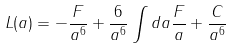<formula> <loc_0><loc_0><loc_500><loc_500>L ( a ) = - \frac { F } { a ^ { 6 } } + \frac { 6 } { a ^ { 6 } } \int d a \frac { F } { a } + \frac { C } { a ^ { 6 } }</formula> 